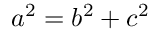<formula> <loc_0><loc_0><loc_500><loc_500>a ^ { 2 } = b ^ { 2 } + c ^ { 2 }</formula> 